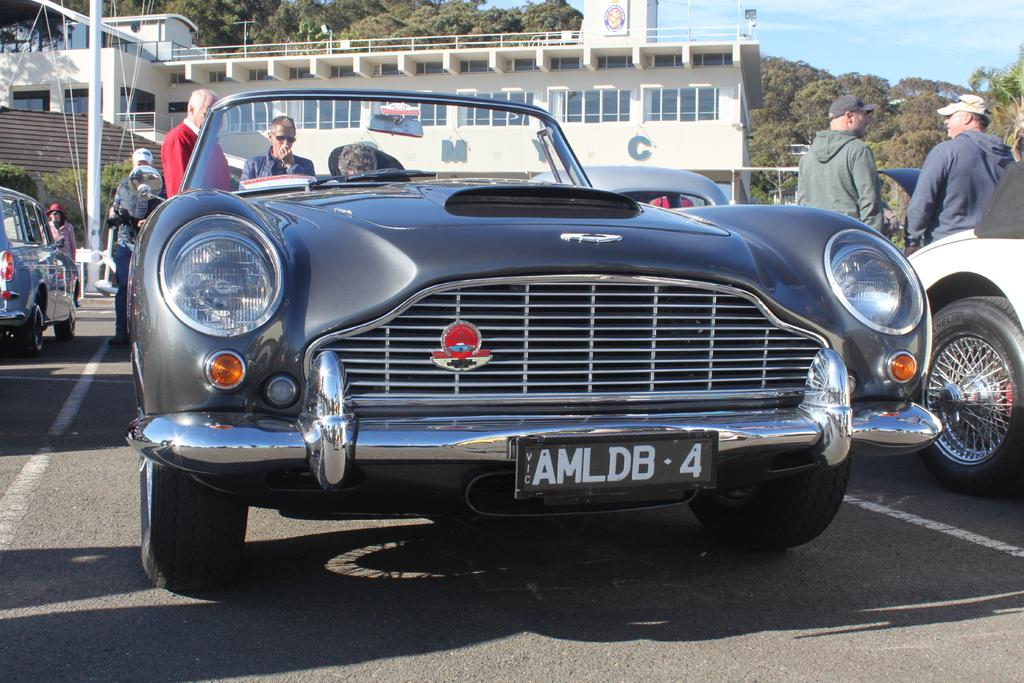What is the main subject of the image? The main subject of the image is a car. What can be seen in the background of the image? In the background of the image, there are people standing, other vehicles, a building, trees, and the sky. How many vehicles can be seen in the image? There is at least one car and other vehicles visible in the background, so there are at least two vehicles in the image. What type of beast is roaming around in the image? There is no beast present in the image; it features a car and various background elements. 